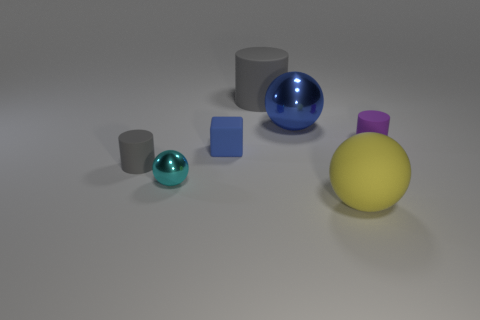What is the material of the gray cylinder that is in front of the blue block?
Provide a succinct answer. Rubber. What number of objects are either big gray matte things or rubber objects that are to the left of the tiny purple matte object?
Your answer should be compact. 4. There is a purple thing that is the same size as the rubber block; what is its shape?
Your answer should be compact. Cylinder. What number of cylinders are the same color as the small sphere?
Offer a terse response. 0. Are the blue thing right of the large gray matte cylinder and the large gray thing made of the same material?
Your response must be concise. No. The large yellow matte thing is what shape?
Ensure brevity in your answer.  Sphere. How many gray things are large shiny balls or large things?
Offer a very short reply. 1. What number of other objects are there of the same material as the small purple cylinder?
Offer a terse response. 4. Does the metal thing that is to the right of the big gray rubber object have the same shape as the small blue matte thing?
Offer a very short reply. No. Are there any tiny brown matte cubes?
Ensure brevity in your answer.  No. 